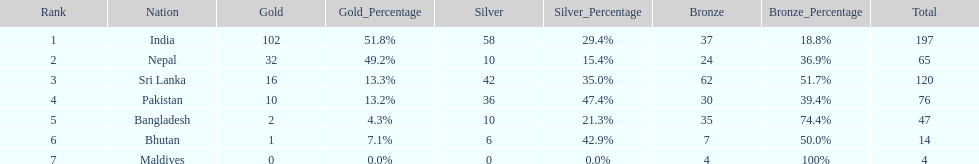How many gold medals were awarded between all 7 nations? 163. 